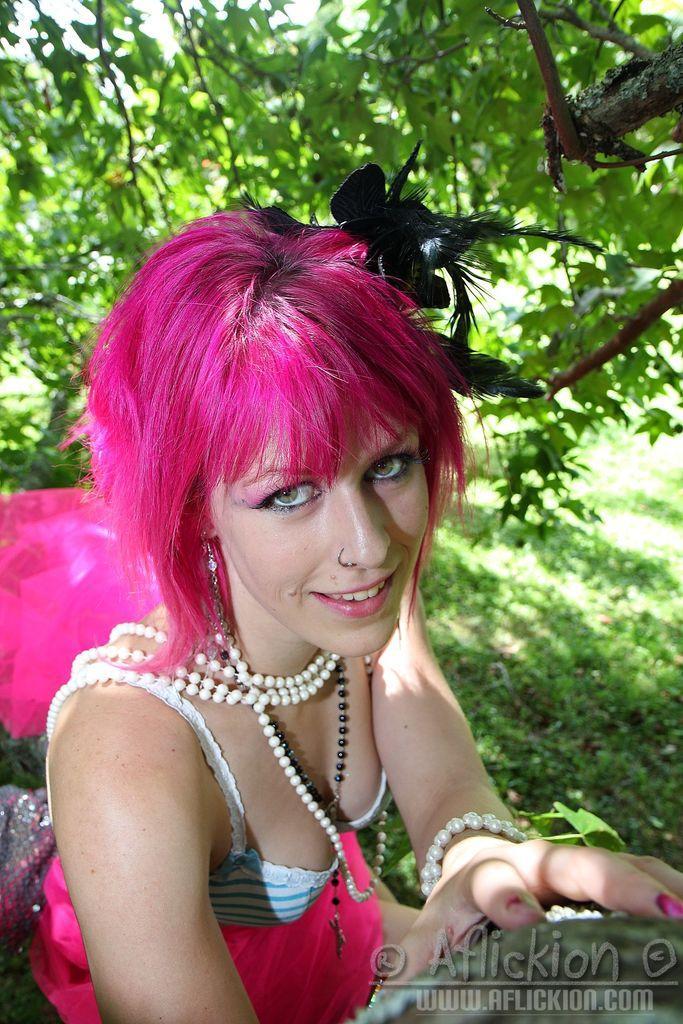In one or two sentences, can you explain what this image depicts? In this image I can see a woman is looking at this side, she has pink color hair. At the top there are trees, at the bottom there is the water mark. 